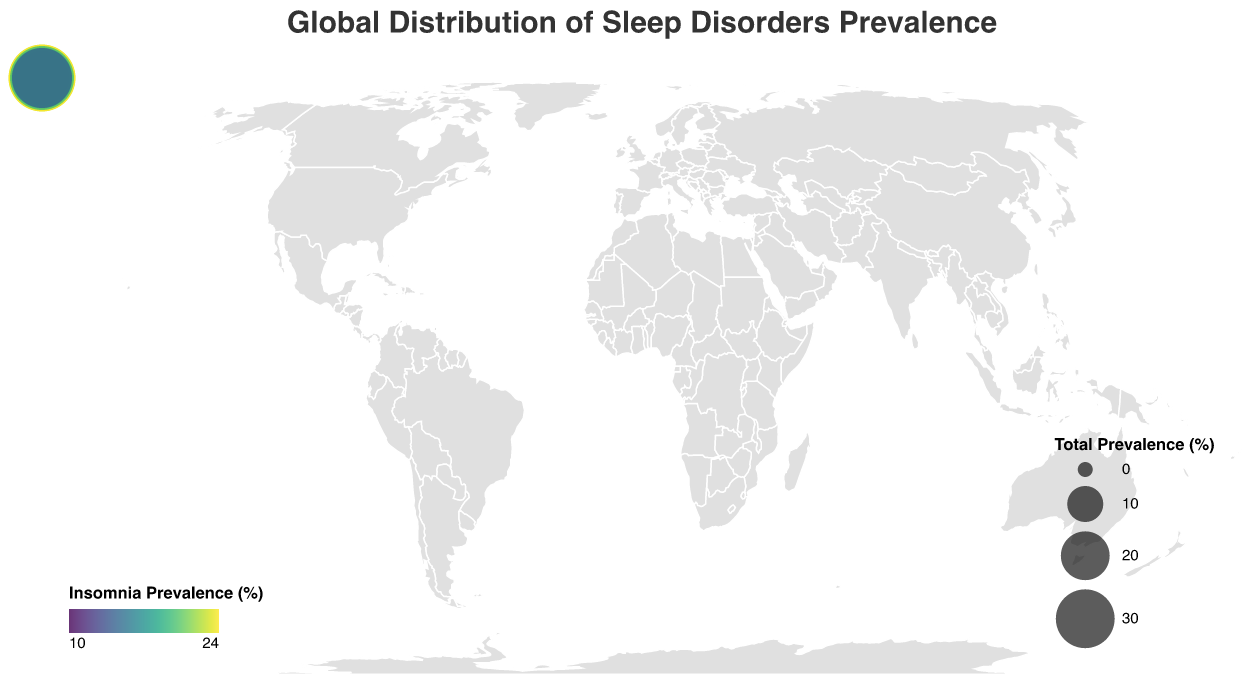Which country has the highest prevalence of insomnia? The plot shows prevalence percentages for insomnia in different countries. According to the data, Canada has the highest insomnia prevalence.
Answer: Canada What is the total prevalence of sleep disorders in the United States? The total prevalence is the sum of the individual disorder percentages. For the United States: 18.5 (Insomnia) + 5.9 (Sleep Apnea) + 0.05 (Narcolepsy) + 7.6 (Restless Leg Syndrome) + 4.2 (Parasomnia) = 36.25
Answer: 36.25 How does the prevalence of narcolepsy in China compare to Japan? The plot shows that in China, narcolepsy prevalence is 0.02%, and in Japan, it is 0.03%. Therefore, narcolepsy prevalence is higher in Japan than in China.
Answer: Japan What are the color and size variations in the visual representation of Canada, and what do they signify? The color and size of the data point for Canada indicate the prevalence of insomnia and the total prevalence of sleep disorders, respectively. The color scale represents the prevalence of insomnia, and Canada is towards the higher end. The circle's size shows the combined total prevalence of all disorders, which is also among the highest.
Answer: High insomnia prevalence and high total prevalence Which country has the least prevalence of insomnia, and what is it? By examining the plot, the least prevalence of insomnia is observed in India with a prevalence rate of 9.5%.
Answer: India Compare the total prevalence of sleep disorders between Germany and Mexico. For Germany: 22.9 (Insomnia) + 4.8 (Sleep Apnea) + 0.04 (Narcolepsy) + 8.8 (Restless Leg Syndrome) + 3.1 (Parasomnia) = 39.64; for Mexico: 13.9 (Insomnia) + 6.7 (Sleep Apnea) + 0.03 (Narcolepsy) + 5.7 (Restless Leg Syndrome) + 5.1 (Parasomnia) = 31.43. Therefore, Germany has a higher total prevalence than Mexico.
Answer: Germany Which sleep disorder has the highest prevalence in South Africa? Based on the data, sleep apnea has the highest prevalence in South Africa at 7.8%.
Answer: Sleep Apnea How does the prevalence of parasomnia in Brazil compare to that in South Africa? Brazil has a parasomnia prevalence of 5.3%, and South Africa has a prevalence of 4.9%. Therefore, parasomnia prevalence is higher in Brazil than in South Africa.
Answer: Brazil What is the average prevalence of restless leg syndrome across all countries listed? Add the restless leg syndrome prevalence for all countries and divide by the number of countries: (7.6+5.2+3.9+8.8+6.4+2.7+4.5+7.2+6.8+3.5+8.1+5.7) / 12 = 5.558.
Answer: 5.56 